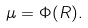Convert formula to latex. <formula><loc_0><loc_0><loc_500><loc_500>\mu = \Phi ( R ) .</formula> 